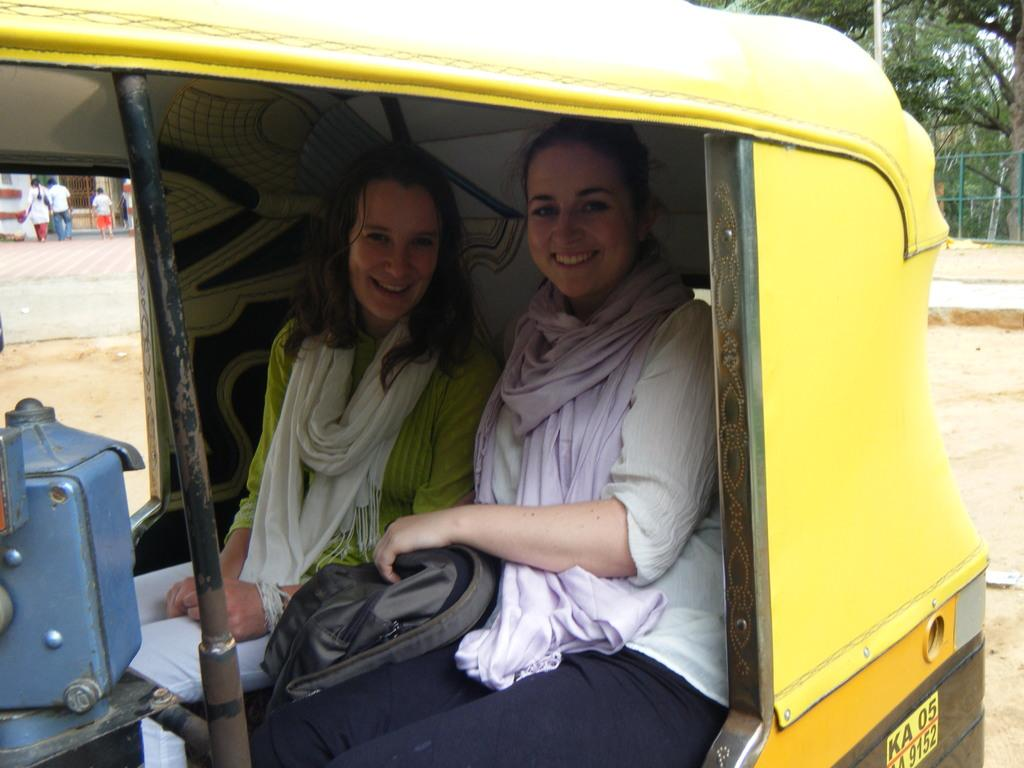What are the women in the image doing? The two women are sitting in an auto. Can you describe the setting of the image? There are other people standing on the footpath behind the auto. What is the value of the produce being sold by the women in the image? There is no indication of any produce being sold by the women in the image. The women are sitting in an auto, and there are people standing on the footpath behind the auto. 